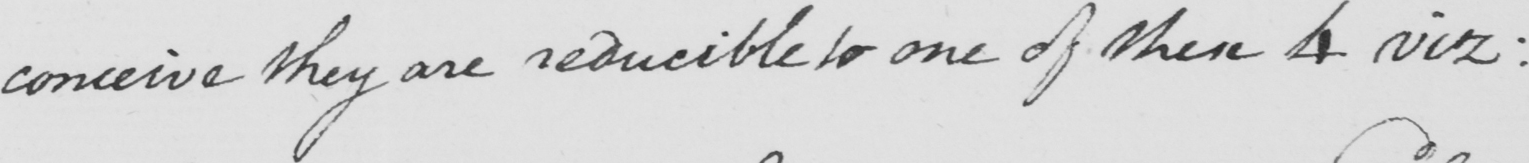Please provide the text content of this handwritten line. conceive they are reducible to one of these 4 viz : 